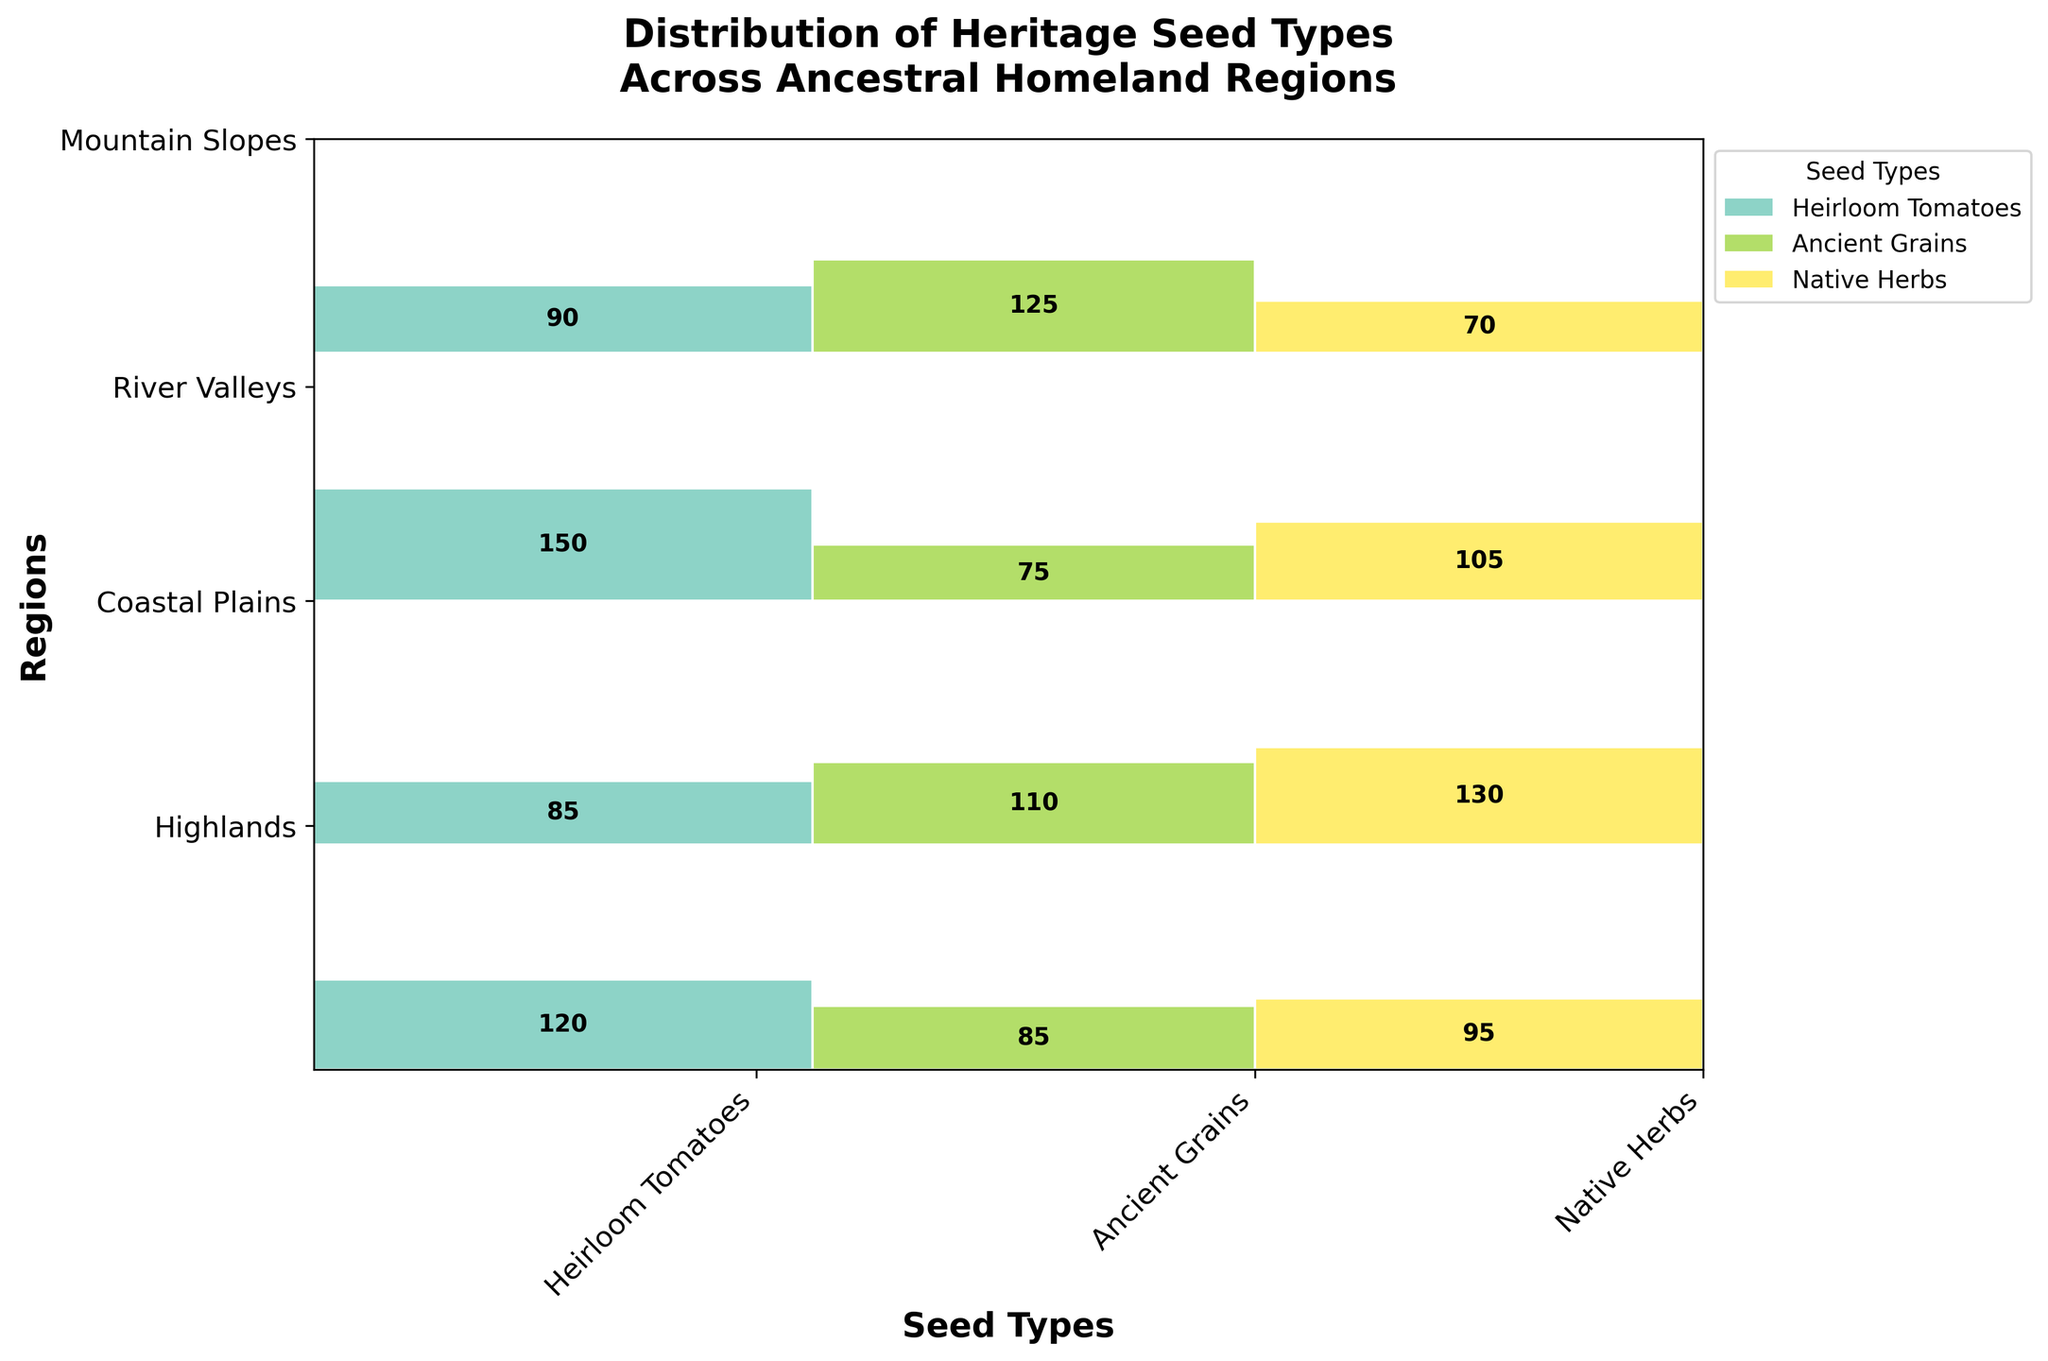How many regions are included in the Mosaic Plot? By looking at the y-axis of the plot, we see the different regions listed as Highlands, Coastal Plains, River Valleys, and Mountain Slopes.
Answer: 4 Which region has the highest count of Native Herbs? Look at the rectangles corresponding to Native Herbs for each region. The Coastal Plains have the largest section for Native Herbs.
Answer: Coastal Plains What is the total count of Heirloom Tomatoes across all regions? Sum the individual counts of Heirloom Tomatoes in each region: 120 (Highlands) + 85 (Coastal Plains) + 150 (River Valleys) + 90 (Mountain Slopes) = 445.
Answer: 445 Compare the counts of Ancient Grains and Native Herbs in the Highlands. Which seed type has a greater count? In the Highlands, Ancient Grains have a count of 85, and Native Herbs have a count of 95. Native Herbs have a greater count.
Answer: Native Herbs Which seed type has the smallest total count across all regions? Sum the counts for each seed type:
- Heirloom Tomatoes: 120 + 85 + 150 + 90 = 445
- Ancient Grains: 85 + 110 + 75 + 125 = 395
- Native Herbs: 95 + 130 + 105 + 70 = 400
Ancient Grains have the smallest total count.
Answer: Ancient Grains Which region has the smallest proportion of Heirloom Tomatoes relative to its own total seed count? Calculate the proportion of Heirloom Tomatoes in each region:
- Highlands: 120 / (120 + 85 + 95) = 120 / 300 = 0.4
- Coastal Plains: 85 / (85 + 110 + 130) = 85 / 325 = 0.2615
- River Valleys: 150 / (150 + 75 + 105) = 150 / 330 = 0.4545
- Mountain Slopes: 90 / (90 + 125 + 70) = 90 / 285 = 0.3158
The Coastal Plains have the smallest proportion of Heirloom Tomatoes.
Answer: Coastal Plains By how much does the count of Native Herbs in the Coastal Plains exceed the count of Native Herbs in the Mountain Slopes? The count of Native Herbs is 130 in Coastal Plains and 70 in Mountain Slopes. The difference is 130 - 70 = 60.
Answer: 60 What is the total count of seeds in the River Valleys region? Sum the counts of all seed types in the River Valleys: 150 (Heirloom Tomatoes) + 75 (Ancient Grains) + 105 (Native Herbs) = 330.
Answer: 330 Which seed type has the largest rectangle (in terms of area) in the Mosaic Plot? Calculate the area for each seed type across all regions by using the proportions:
- Heirloom Tomatoes: 445 / total (1240) = 0.358
- Ancient Grains: 395 / total (1240) = 0.318
- Native Herbs: 400 / total (1240) = 0.323
Heirloom Tomatoes have the largest area.
Answer: Heirloom Tomatoes Which region has the smallest total seed count? Compare the total counts for each region:
- Highlands: 300
- Coastal Plains: 325
- River Valleys: 330
- Mountain Slopes: 285
Mountain Slopes have the smallest total seed count.
Answer: Mountain Slopes 